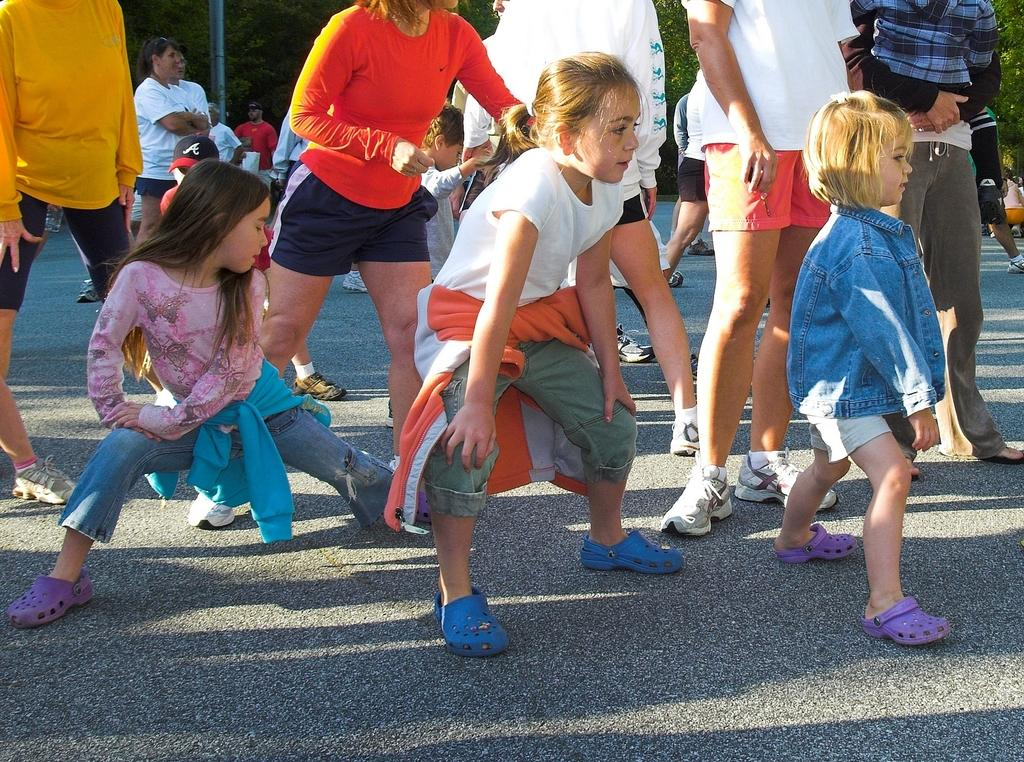What can be seen in the image involving young individuals? There are children standing in the image. Who else is present in the image besides the children? There are people in the image. What type of man-made structure is visible in the image? There is a road visible in the image. What type of natural elements can be seen in the image? There are trees in the image. What type of feather can be seen on the horse in the image? There is no horse or feather present in the image. What date is marked on the calendar in the image? There is no calendar present in the image. 